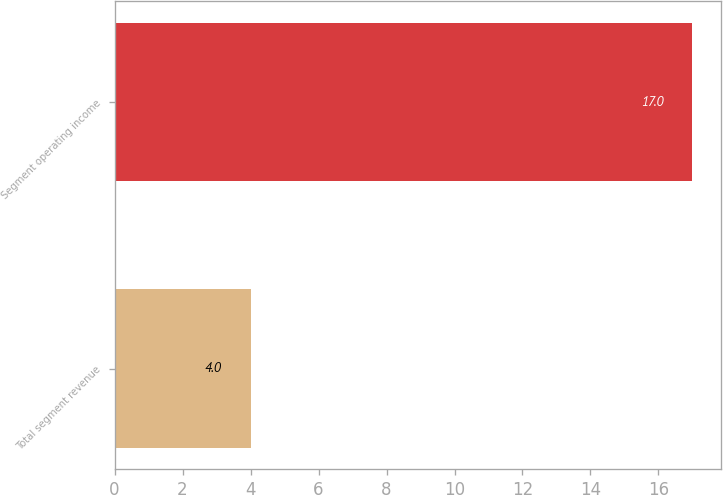Convert chart. <chart><loc_0><loc_0><loc_500><loc_500><bar_chart><fcel>Total segment revenue<fcel>Segment operating income<nl><fcel>4<fcel>17<nl></chart> 